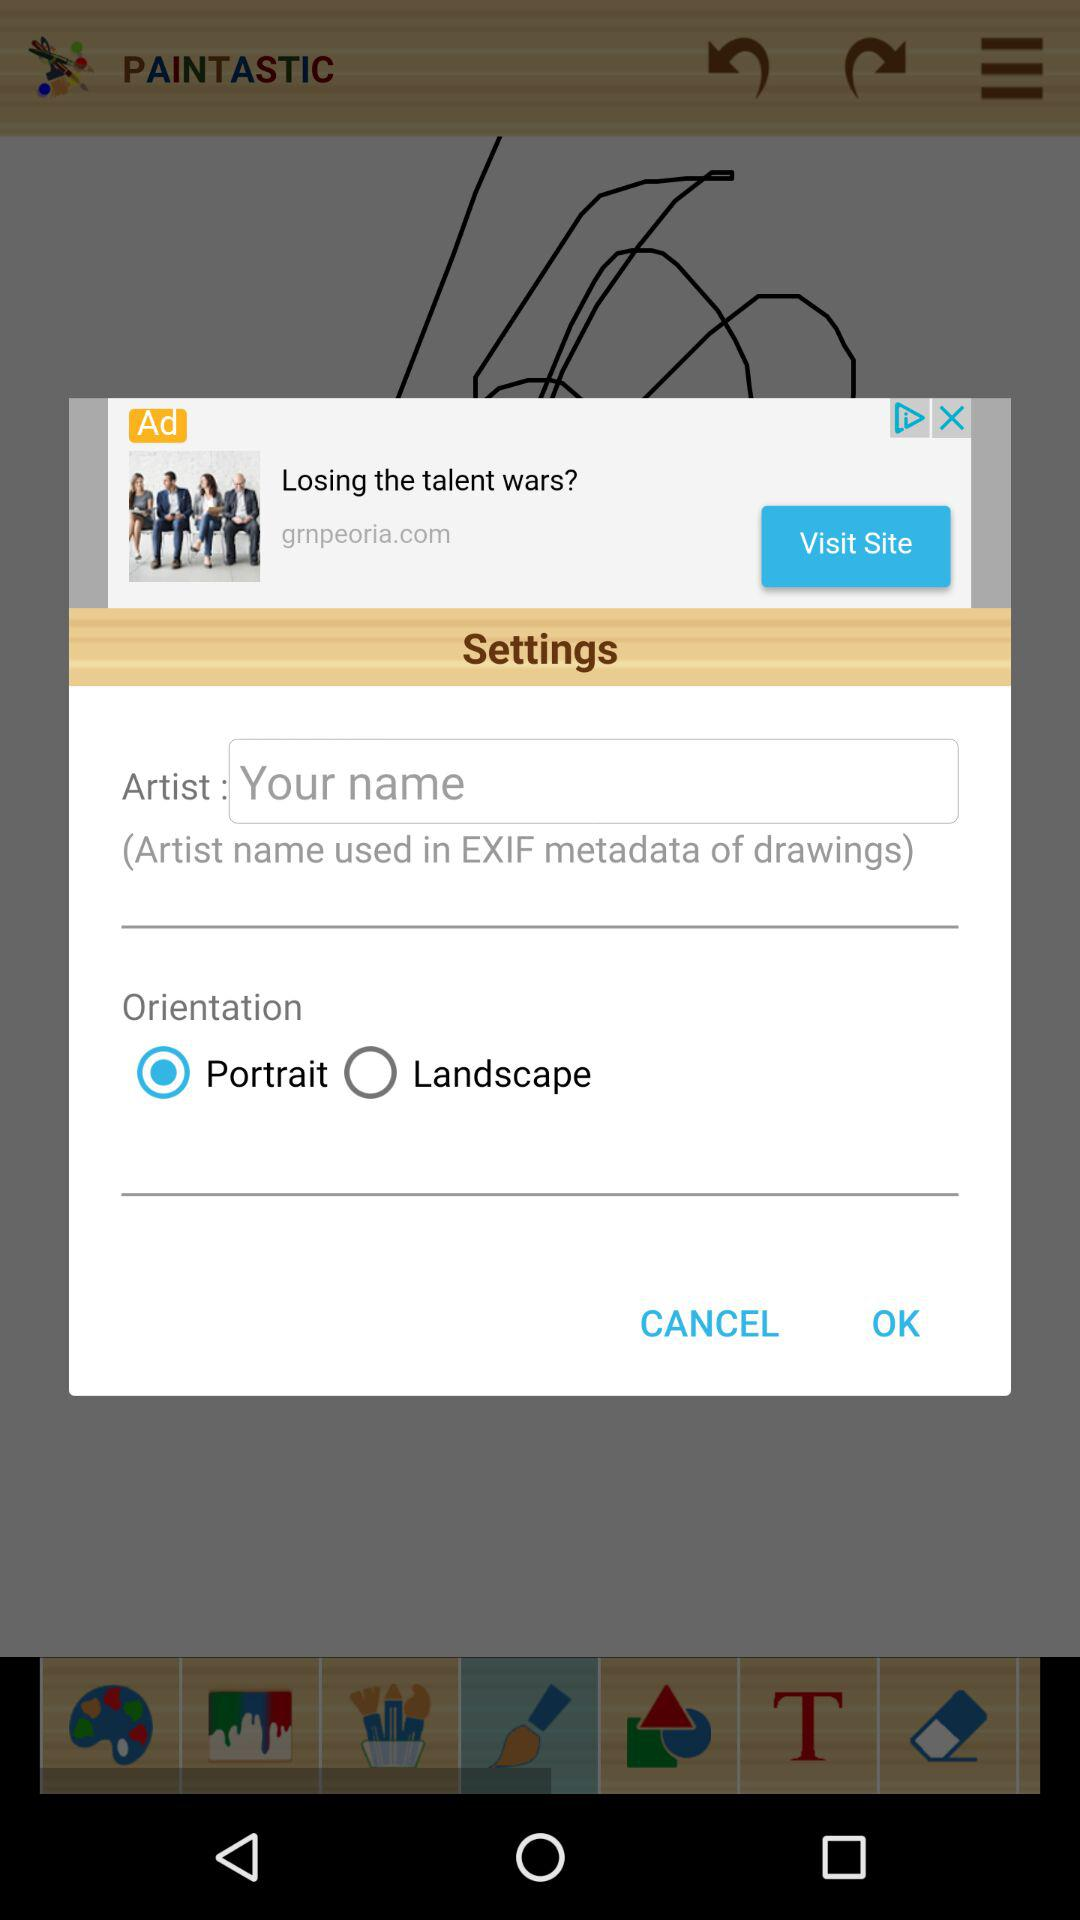Which option has been selected? The option that has been selected is "Portrait". 